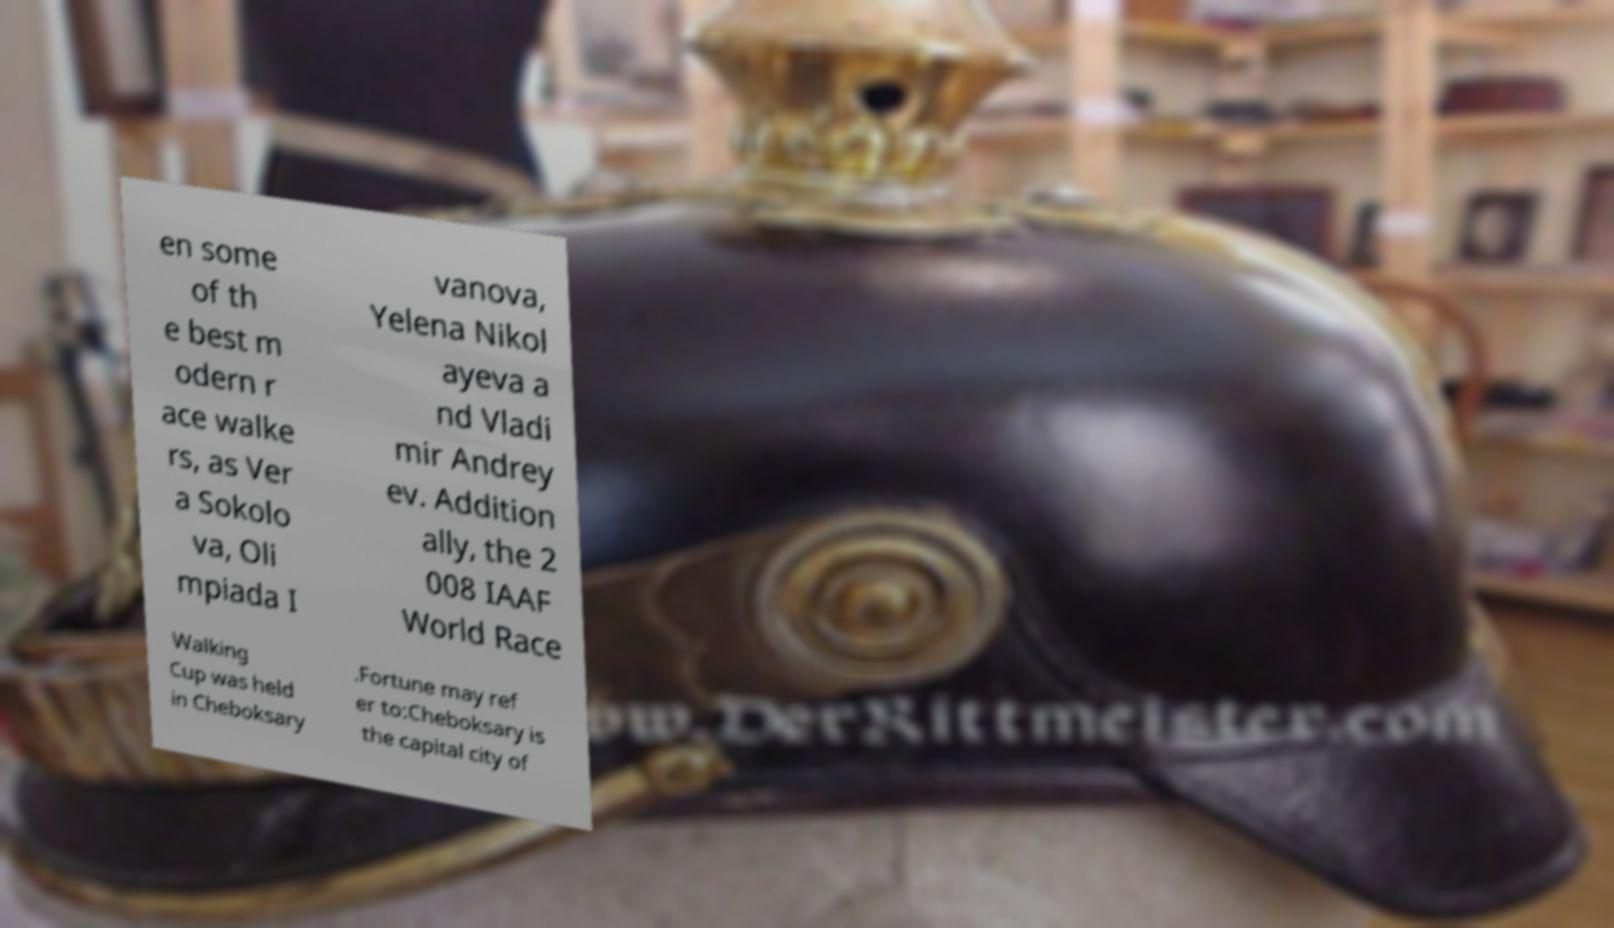Please identify and transcribe the text found in this image. en some of th e best m odern r ace walke rs, as Ver a Sokolo va, Oli mpiada I vanova, Yelena Nikol ayeva a nd Vladi mir Andrey ev. Addition ally, the 2 008 IAAF World Race Walking Cup was held in Cheboksary .Fortune may ref er to:Cheboksary is the capital city of 